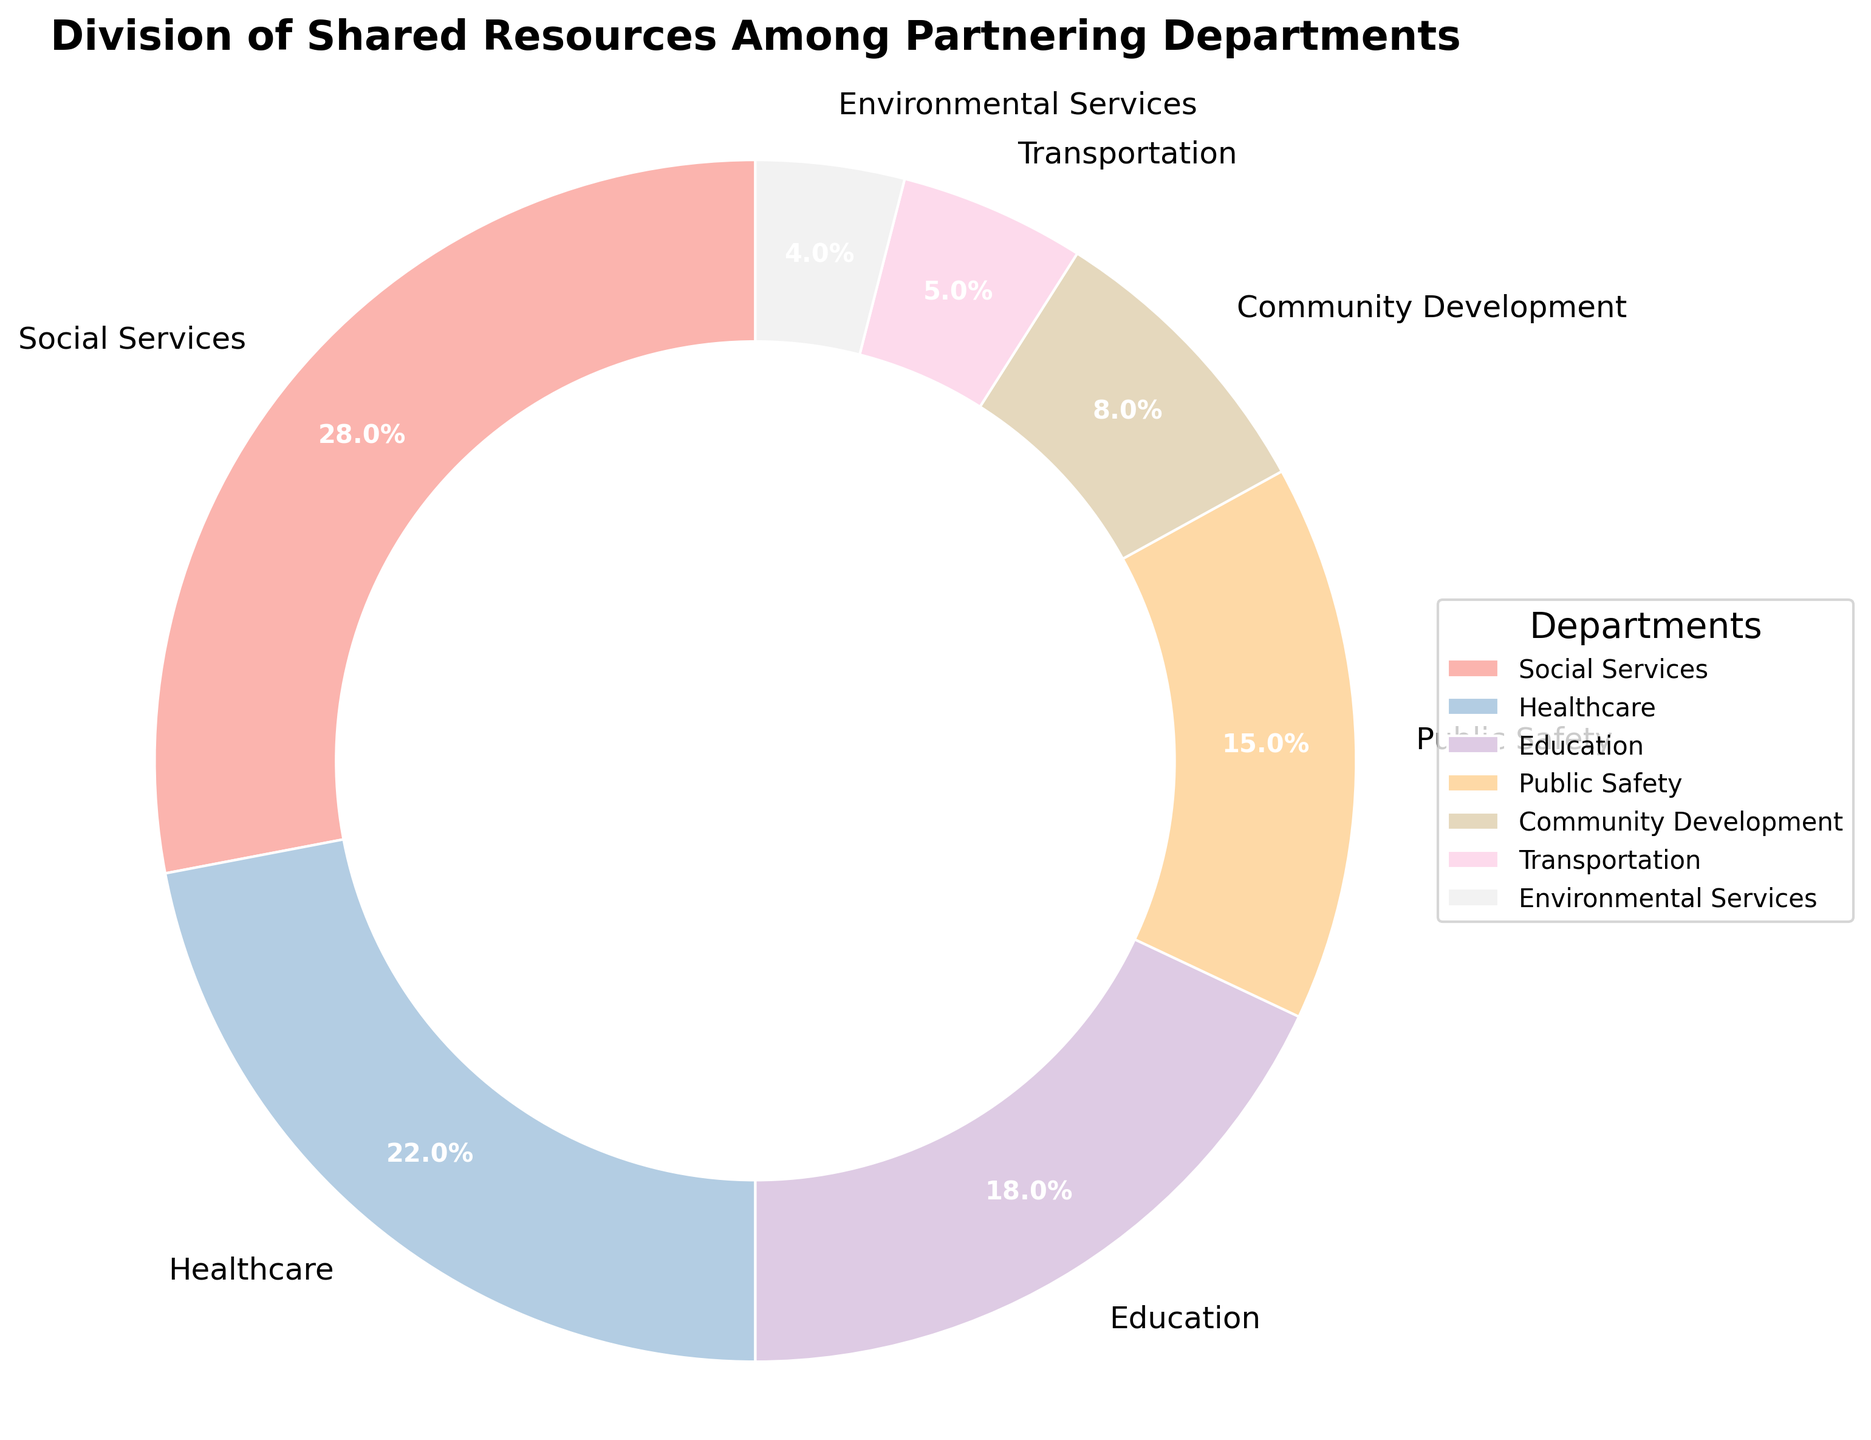Which department received the highest percentage of resource allocation? From the pie chart, observe the labels and corresponding percentages. Social Services has the highest percentage allocation of 28%.
Answer: Social Services Which departments have a combined resource allocation of more than 50%? Adding the percentages for Social Services (28%) and Healthcare (22%), we get 50%, which is equal to half. Adding Education (18%) makes it 68%, which is more than 50%. So, Social Services, Healthcare, and Education combined have more than 50%.
Answer: Social Services, Healthcare, Education Which department received the least percentage of resource allocation, and what is its percentage? Look for the smallest slice in the pie chart; Environmental Services has the smallest allocation with 4%.
Answer: Environmental Services, 4% How does the resource allocation for Public Safety compare to that for Community Development? Public Safety has 15% allocation, while Community Development has 8%. Since 15% is greater than 8%, Public Safety has a higher allocation than Community Development.
Answer: Public Safety > Community Development Which department's resource allocation percentage is closest to the average allocation of all departments? First, calculate the average percentage: (28 + 22 + 18 + 15 + 8 + 5 + 4) / 7 = 14.2857. The closest percentage to this average is Public Safety with 15%.
Answer: Public Safety How much more of the resources are allocated to Social Services compared to Transportation? Social Services has 28% and Transportation has 5%. The difference is 28% - 5% = 23%.
Answer: 23% What proportion of the total allocation is received by the three least funded departments? Adding the percentages for Community Development (8%), Transportation (5%), and Environmental Services (4%) gives 8% + 5% + 4% = 17%.
Answer: 17% Does the sum of the allocations for Healthcare and Education exceed that for Social Services? Healthcare has 22% and Education has 18%. Their combined allocation is 22% + 18% = 40%, which is greater than Social Services' allocation of 28%.
Answer: Yes Which department's allocation is visually the largest and what color is it represented by in the chart? Social Services has the highest allocation at 28%, and it is represented by the largest slice of the pie chart. Based on the colormap (Pastel1), we can infer it is likely one of the prominent colors it is shown in.
Answer: Social Services, (color represented in the chart) What is the difference in resource allocation percentage between the two largest allocations? The two largest allocations are Social Services (28%) and Healthcare (22%). The difference is 28% - 22% = 6%.
Answer: 6% 